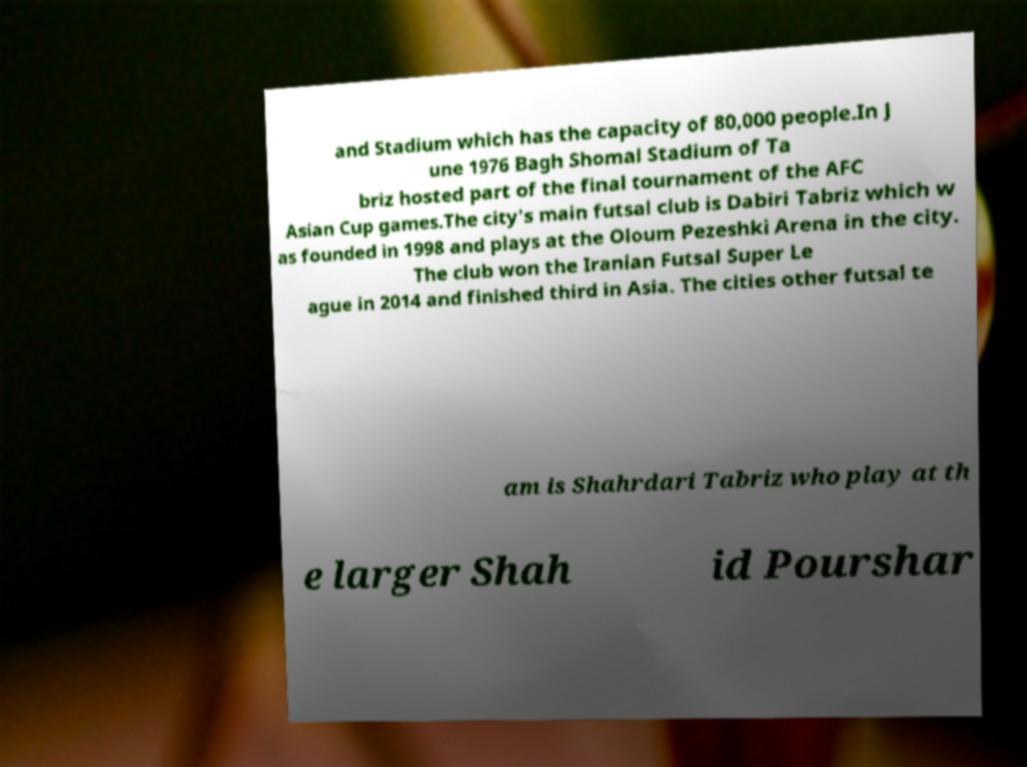There's text embedded in this image that I need extracted. Can you transcribe it verbatim? and Stadium which has the capacity of 80,000 people.In J une 1976 Bagh Shomal Stadium of Ta briz hosted part of the final tournament of the AFC Asian Cup games.The city's main futsal club is Dabiri Tabriz which w as founded in 1998 and plays at the Oloum Pezeshki Arena in the city. The club won the Iranian Futsal Super Le ague in 2014 and finished third in Asia. The cities other futsal te am is Shahrdari Tabriz who play at th e larger Shah id Pourshar 